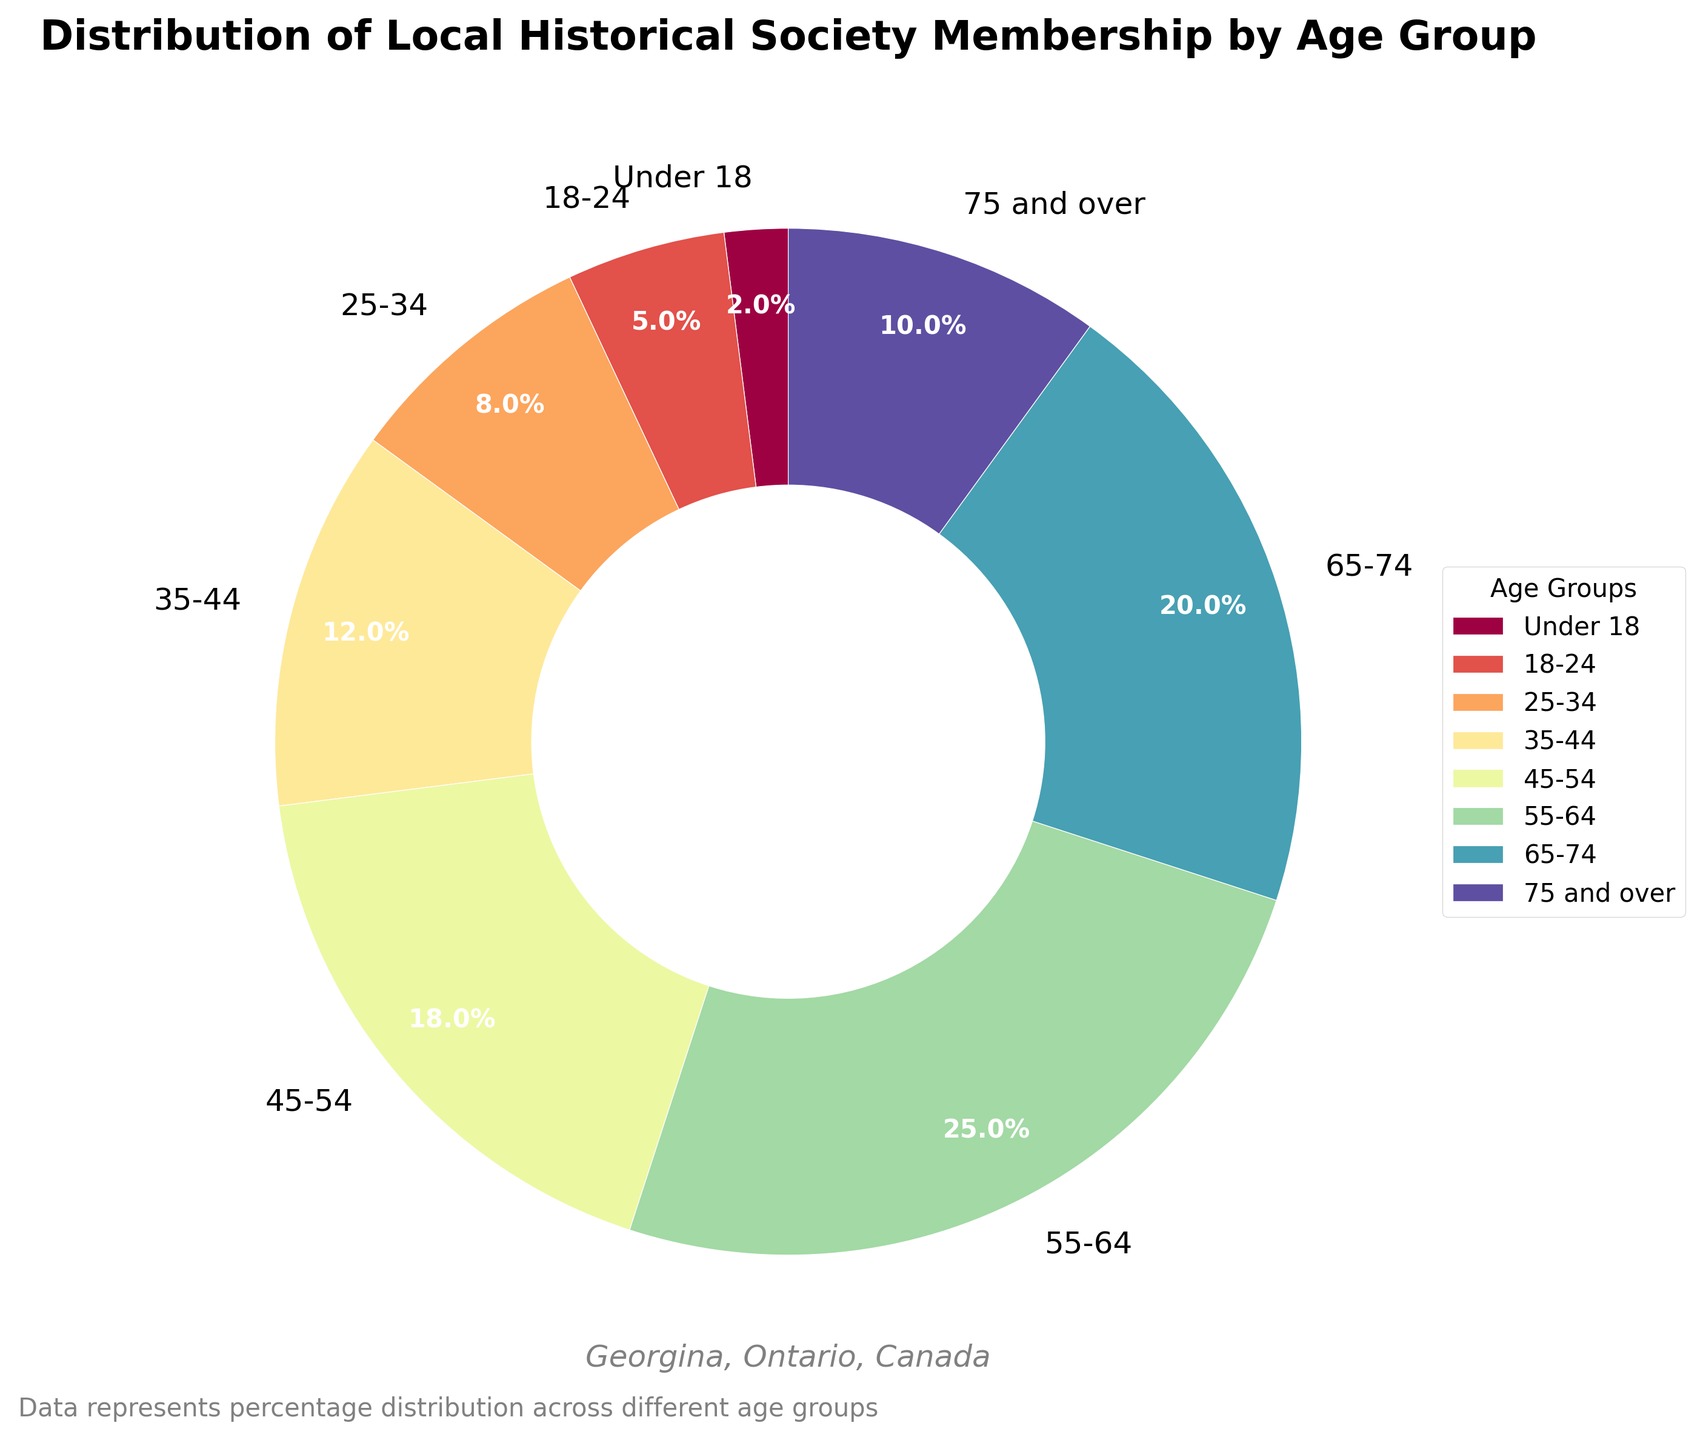Which age group has the largest percentage of members? The age group "55-64" has the largest percentage of members as indicated directly by the slice size and the label.
Answer: 55-64 What is the combined percentage of members under the age of 25? Add the percentage for "Under 18" and "18-24". 2% + 5% = 7%.
Answer: 7% Which age group has the smallest representation in the local historical society? The age group "Under 18" has the smallest slice and corresponding percentage label.
Answer: Under 18 How does the percentage of members aged 45-54 compare with those aged 75 and over? The percentage for ages 45-54 is 18%, while for ages 75 and over it is 10%. 18% is greater than 10%.
Answer: 45-54 has a higher percentage What percentage of members are aged 55 or older? Add the percentages of the age groups 55-64, 65-74, and 75 and over. 25% + 20% + 10% = 55%.
Answer: 55% Is the percentage of members aged 35-44 higher than those aged 25-34? Yes, the percentage for ages 35-44 is 12%, while for ages 25-34 it is 8%. 12% is greater than 8%.
Answer: Yes What is the difference in the percentage of members between the 25-34 age group and the 45-54 age group? Subtract the percentage for the 25-34 age group from the 45-54 age group. 18% - 8% = 10%.
Answer: 10% Based on the visual attributes, which age group is represented by the most vibrant color? The pie chart uses the Spectral color map, which assigns the most vibrant color (typically red) centrally. The middle age group, 45-54, is represented by the most vibrant color.
Answer: 45-54 What is the ratio of members aged 65-74 to those aged 35-44? Divide the percentage for the 65-74 age group by the 35-44 age group. 20% / 12% ≈ 1.67
Answer: 1.67 Which age groups collectively form more than half of the society's membership? Add the percentages and identify groups that sum up to more than 50%. 55-64 (25%) + 65-74 (20%) + 45-54 (18%) = 63%. These three groups collectively form more than half.
Answer: 55-64, 65-74, 45-54 